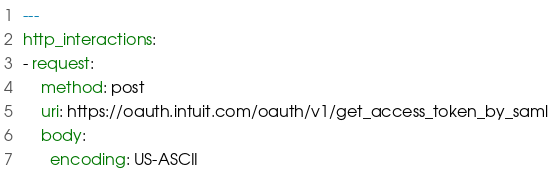Convert code to text. <code><loc_0><loc_0><loc_500><loc_500><_YAML_>---
http_interactions:
- request:
    method: post
    uri: https://oauth.intuit.com/oauth/v1/get_access_token_by_saml
    body:
      encoding: US-ASCII</code> 